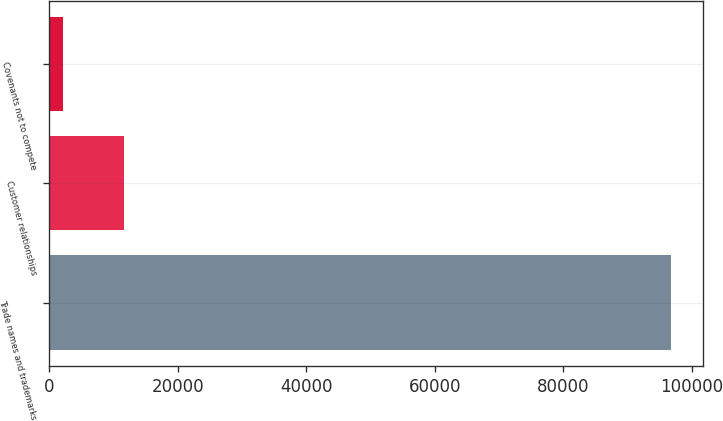Convert chart. <chart><loc_0><loc_0><loc_500><loc_500><bar_chart><fcel>Trade names and trademarks<fcel>Customer relationships<fcel>Covenants not to compete<nl><fcel>96823<fcel>11579.5<fcel>2108<nl></chart> 